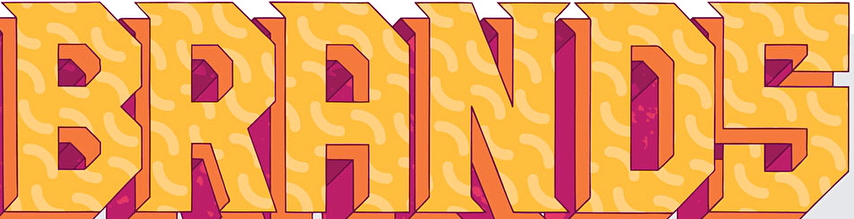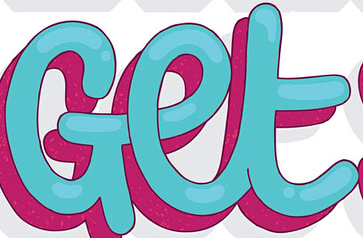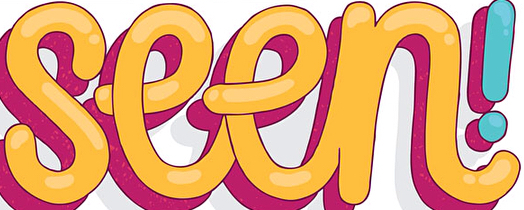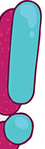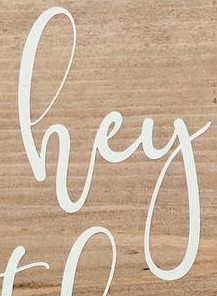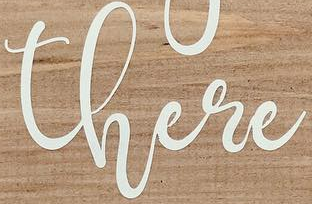What words can you see in these images in sequence, separated by a semicolon? BRANDS; Get; seen; !; hey; there 